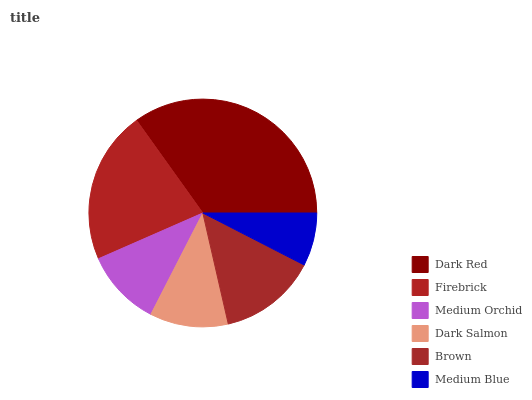Is Medium Blue the minimum?
Answer yes or no. Yes. Is Dark Red the maximum?
Answer yes or no. Yes. Is Firebrick the minimum?
Answer yes or no. No. Is Firebrick the maximum?
Answer yes or no. No. Is Dark Red greater than Firebrick?
Answer yes or no. Yes. Is Firebrick less than Dark Red?
Answer yes or no. Yes. Is Firebrick greater than Dark Red?
Answer yes or no. No. Is Dark Red less than Firebrick?
Answer yes or no. No. Is Brown the high median?
Answer yes or no. Yes. Is Dark Salmon the low median?
Answer yes or no. Yes. Is Dark Red the high median?
Answer yes or no. No. Is Firebrick the low median?
Answer yes or no. No. 